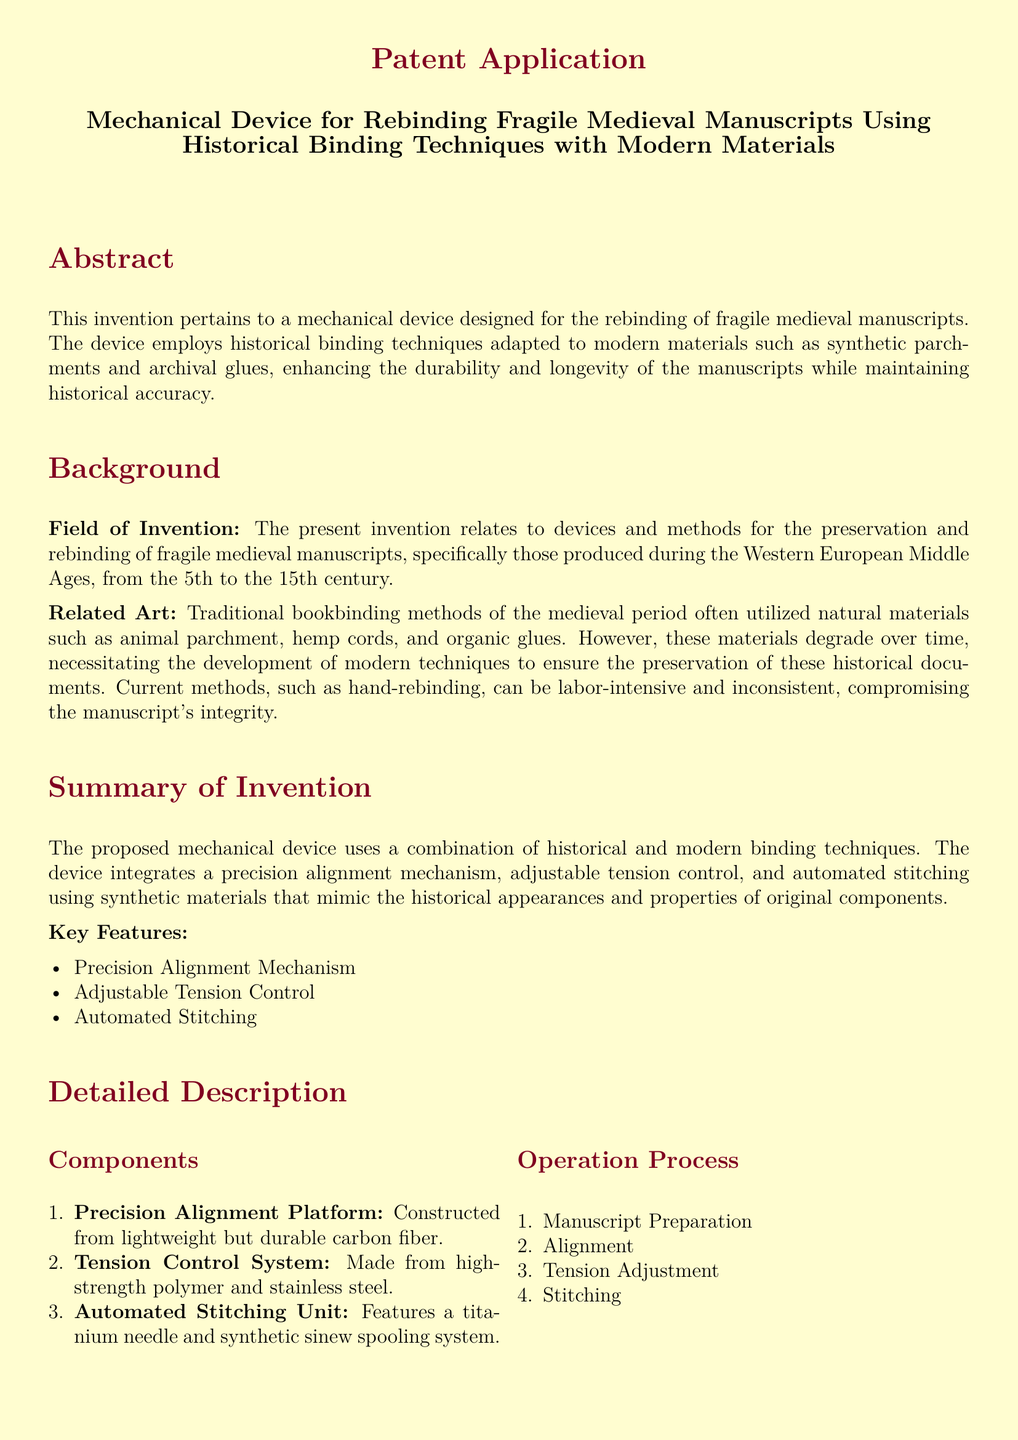What is the title of the invention? The title of the invention is provided at the top of the document, detailing its purpose and focus.
Answer: Mechanical Device for Rebinding Fragile Medieval Manuscripts Using Historical Binding Techniques with Modern Materials What materials are used for the Precision Alignment Platform? The materials used for the Precision Alignment Platform are mentioned in the detailed description of the components.
Answer: Carbon fiber What is one key feature of the proposed mechanical device? The key features are listed under the summary of the invention, outlining its primary innovations.
Answer: Precision Alignment Mechanism What historical period do the manuscripts being preserved originate from? This information can be found in the background section, specifying the timeframe of the manuscripts.
Answer: 5th to 15th century What type of stitching does the Automated Stitching Unit use? The detailed description of the automated stitching unit indicates the type of stitching used.
Answer: Historically accurate stitching patterns What advantage does the device provide in terms of durability? Advantages are listed under a specific section, addressing the benefits of the device in preserving manuscripts.
Answer: Enhanced Durability How many components are listed in the detailed description? The document explicitly lists the number of components in an enumerated format under the section titled Components.
Answer: Three What is the role of the Tension Control System in the device? The role of the system is explained within the detailed description, focusing on its function within the rebinding process.
Answer: Tension adjustment What type of materials does the device utilize for stitching? The materials used for stitching are specified in the claims section related to the automated stitching unit.
Answer: Synthetic sinew 